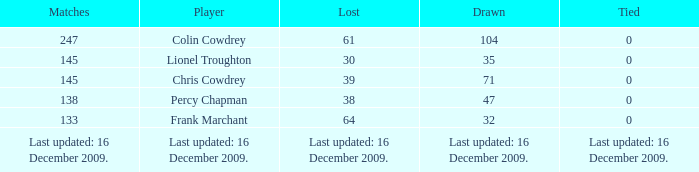I want to know the drawn that has a tie of 0 and the player is chris cowdrey 71.0. 